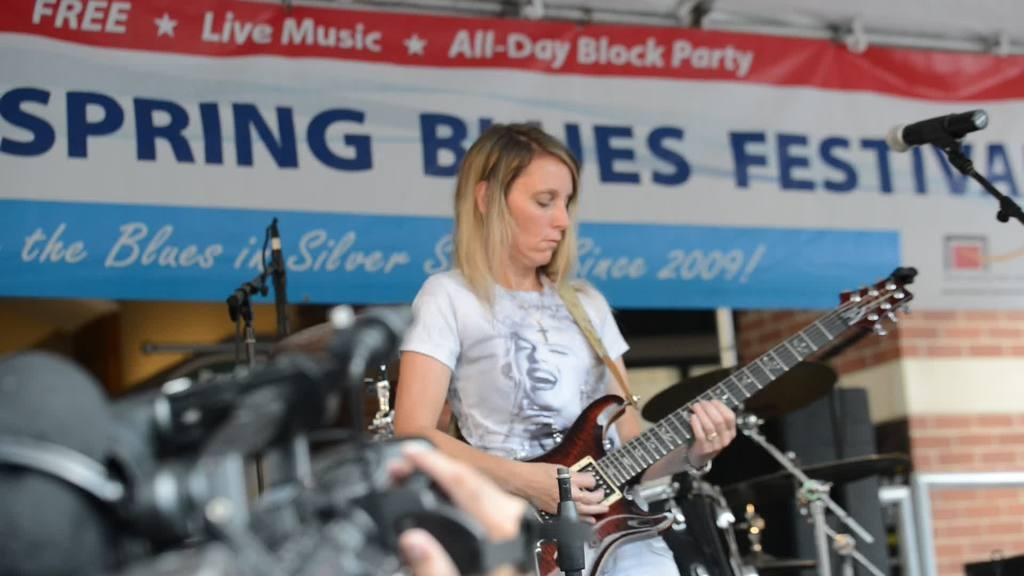Who is the main subject in the image? There is a woman in the image. What is the woman doing in the image? The woman is playing a guitar. What other objects can be seen in the image? There is a microphone, a camera, and a banner in the background of the image. What is the setting of the image? There is a wall in the background of the image. Where is the scarecrow located in the image? There is no scarecrow present in the image. What type of store can be seen in the background of the image? There is no store visible in the image; it features a wall in the background. 